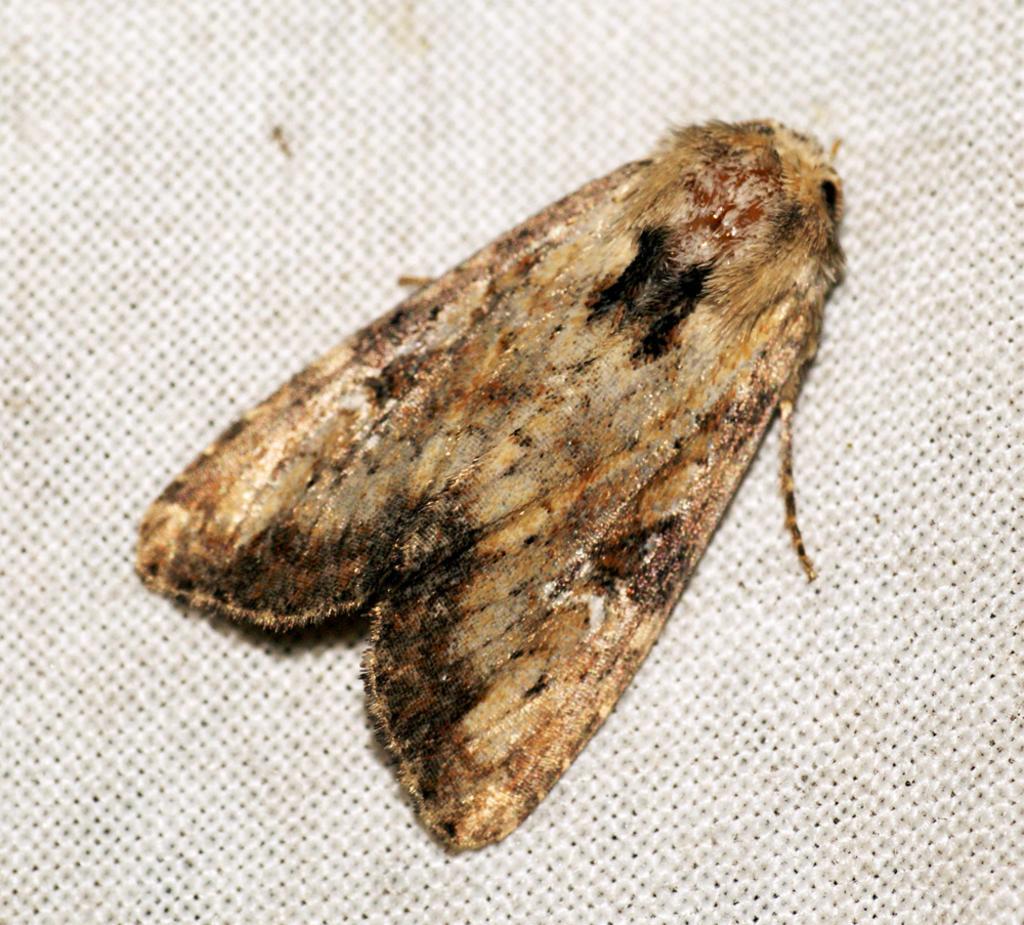Please provide a concise description of this image. Here in this picture we can see a moth represent on a place over there. 